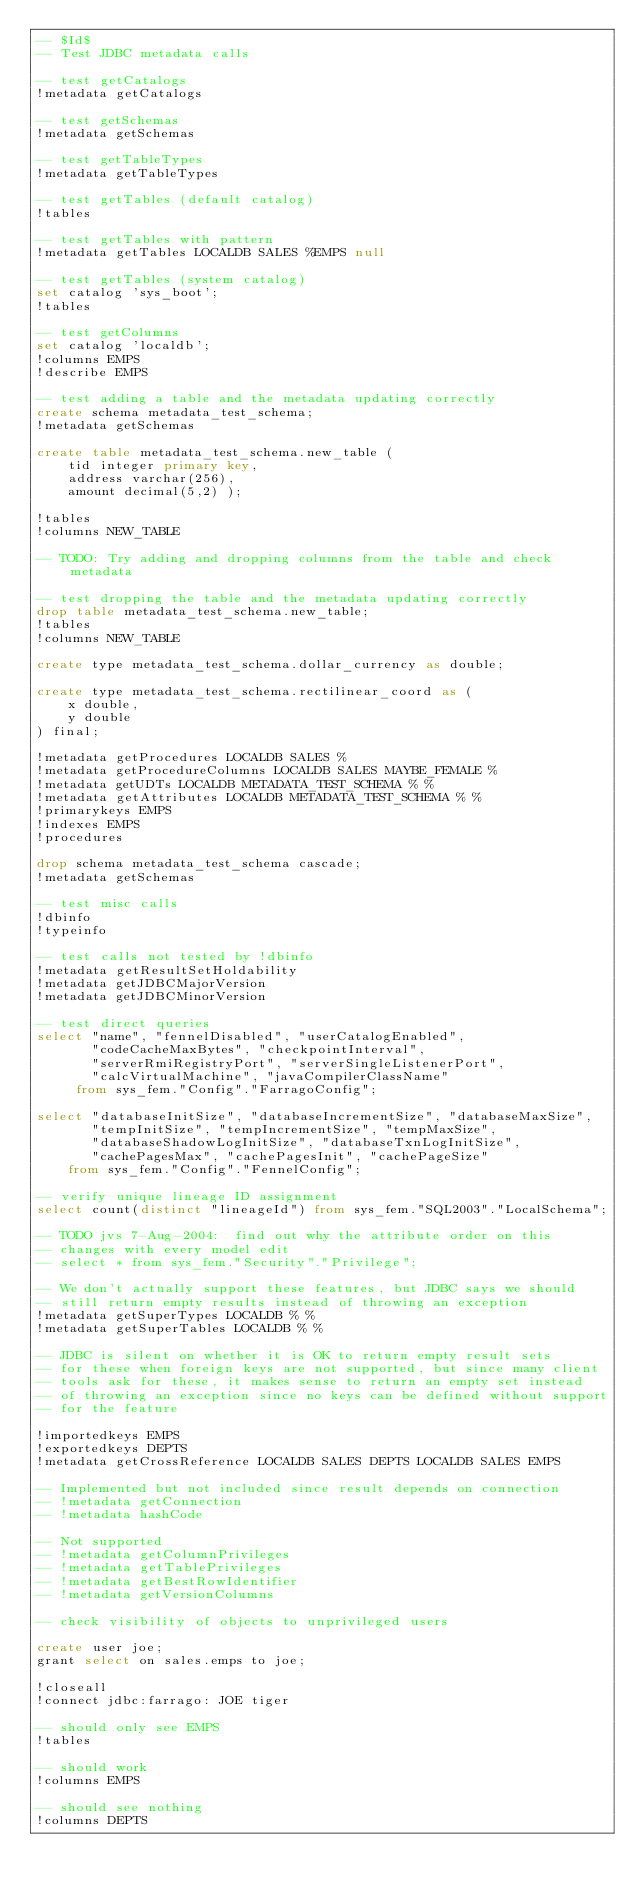<code> <loc_0><loc_0><loc_500><loc_500><_SQL_>-- $Id$
-- Test JDBC metadata calls

-- test getCatalogs
!metadata getCatalogs

-- test getSchemas
!metadata getSchemas

-- test getTableTypes
!metadata getTableTypes

-- test getTables (default catalog)
!tables

-- test getTables with pattern
!metadata getTables LOCALDB SALES %EMPS null

-- test getTables (system catalog)
set catalog 'sys_boot';
!tables

-- test getColumns
set catalog 'localdb';
!columns EMPS
!describe EMPS

-- test adding a table and the metadata updating correctly
create schema metadata_test_schema;
!metadata getSchemas

create table metadata_test_schema.new_table (
    tid integer primary key,
    address varchar(256),
    amount decimal(5,2) );

!tables
!columns NEW_TABLE

-- TODO: Try adding and dropping columns from the table and check metadata

-- test dropping the table and the metadata updating correctly
drop table metadata_test_schema.new_table;
!tables
!columns NEW_TABLE

create type metadata_test_schema.dollar_currency as double;

create type metadata_test_schema.rectilinear_coord as (
    x double,
    y double
) final;

!metadata getProcedures LOCALDB SALES %
!metadata getProcedureColumns LOCALDB SALES MAYBE_FEMALE %
!metadata getUDTs LOCALDB METADATA_TEST_SCHEMA % %
!metadata getAttributes LOCALDB METADATA_TEST_SCHEMA % %
!primarykeys EMPS
!indexes EMPS
!procedures

drop schema metadata_test_schema cascade;
!metadata getSchemas

-- test misc calls
!dbinfo
!typeinfo

-- test calls not tested by !dbinfo
!metadata getResultSetHoldability
!metadata getJDBCMajorVersion
!metadata getJDBCMinorVersion

-- test direct queries
select "name", "fennelDisabled", "userCatalogEnabled",
       "codeCacheMaxBytes", "checkpointInterval",
       "serverRmiRegistryPort", "serverSingleListenerPort",
       "calcVirtualMachine", "javaCompilerClassName"
     from sys_fem."Config"."FarragoConfig";

select "databaseInitSize", "databaseIncrementSize", "databaseMaxSize",
       "tempInitSize", "tempIncrementSize", "tempMaxSize",
       "databaseShadowLogInitSize", "databaseTxnLogInitSize",
       "cachePagesMax", "cachePagesInit", "cachePageSize"
    from sys_fem."Config"."FennelConfig";

-- verify unique lineage ID assignment
select count(distinct "lineageId") from sys_fem."SQL2003"."LocalSchema";

-- TODO jvs 7-Aug-2004:  find out why the attribute order on this
-- changes with every model edit
-- select * from sys_fem."Security"."Privilege";

-- We don't actually support these features, but JDBC says we should
-- still return empty results instead of throwing an exception
!metadata getSuperTypes LOCALDB % %
!metadata getSuperTables LOCALDB % %

-- JDBC is silent on whether it is OK to return empty result sets
-- for these when foreign keys are not supported, but since many client
-- tools ask for these, it makes sense to return an empty set instead
-- of throwing an exception since no keys can be defined without support
-- for the feature

!importedkeys EMPS
!exportedkeys DEPTS
!metadata getCrossReference LOCALDB SALES DEPTS LOCALDB SALES EMPS

-- Implemented but not included since result depends on connection
-- !metadata getConnection
-- !metadata hashCode

-- Not supported
-- !metadata getColumnPrivileges
-- !metadata getTablePrivileges
-- !metadata getBestRowIdentifier
-- !metadata getVersionColumns

-- check visibility of objects to unprivileged users

create user joe;
grant select on sales.emps to joe;

!closeall
!connect jdbc:farrago: JOE tiger

-- should only see EMPS
!tables

-- should work
!columns EMPS

-- should see nothing
!columns DEPTS
</code> 